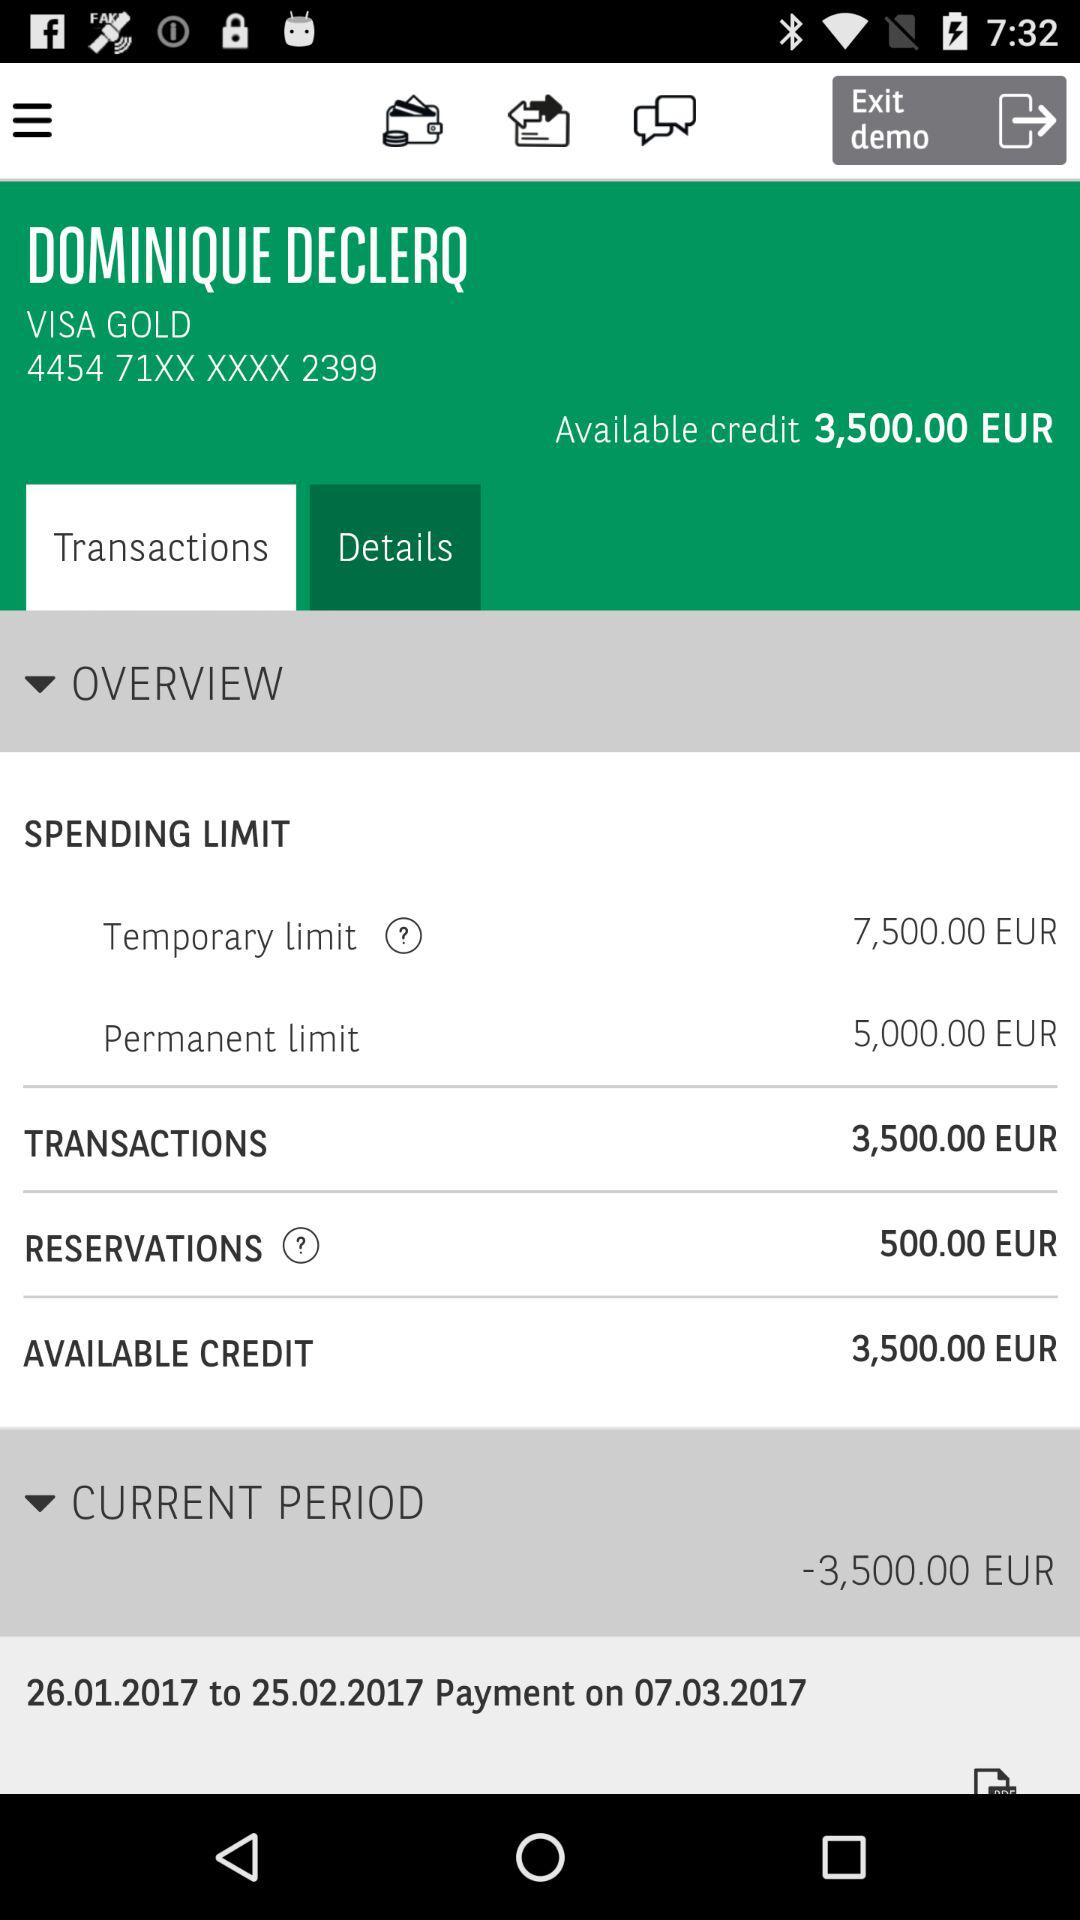What is the reservation amount? The reservation amount is 500.00 euros. 